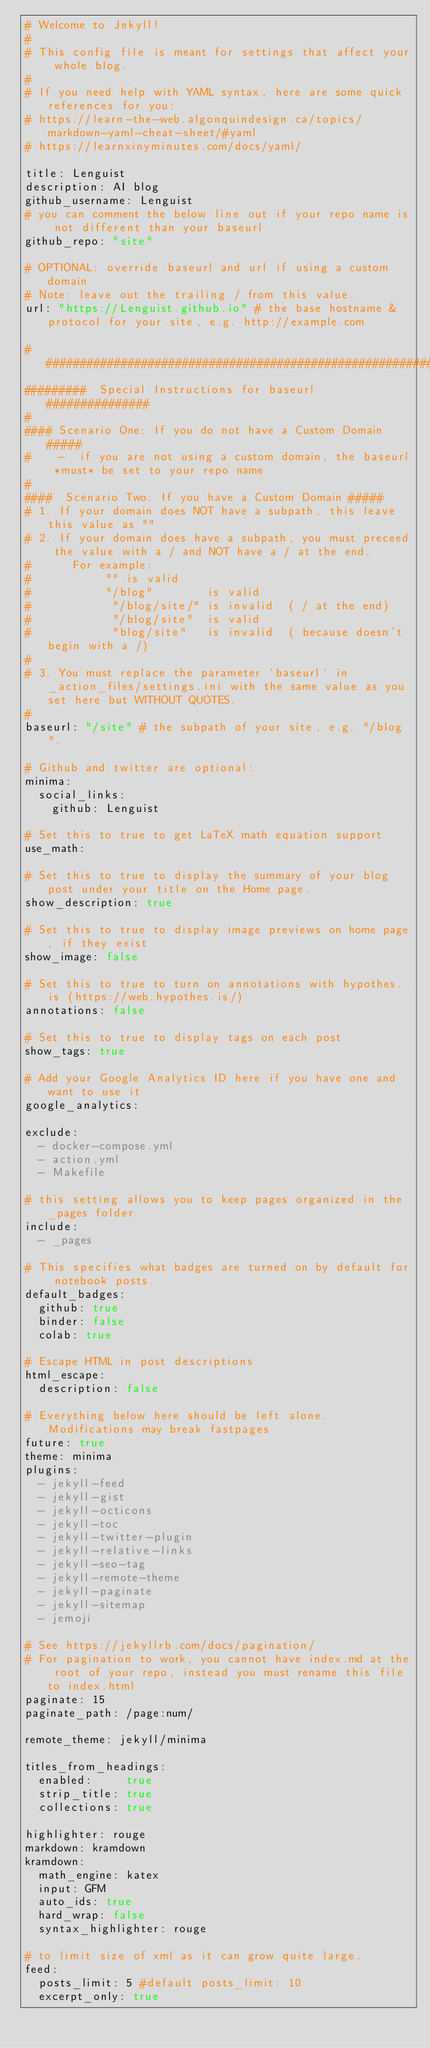Convert code to text. <code><loc_0><loc_0><loc_500><loc_500><_YAML_># Welcome to Jekyll!
#
# This config file is meant for settings that affect your whole blog.
#
# If you need help with YAML syntax, here are some quick references for you: 
# https://learn-the-web.algonquindesign.ca/topics/markdown-yaml-cheat-sheet/#yaml
# https://learnxinyminutes.com/docs/yaml/

title: Lenguist
description: AI blog
github_username: Lenguist
# you can comment the below line out if your repo name is not different than your baseurl
github_repo: "site"

# OPTIONAL: override baseurl and url if using a custom domain
# Note: leave out the trailing / from this value. 
url: "https://Lenguist.github.io" # the base hostname & protocol for your site, e.g. http://example.com

###########################################################
#########  Special Instructions for baseurl ###############
#
#### Scenario One: If you do not have a Custom Domain #####
#    -  if you are not using a custom domain, the baseurl *must* be set to your repo name
# 
####  Scenario Two: If you have a Custom Domain #####
# 1. If your domain does NOT have a subpath, this leave this value as ""
# 2. If your domain does have a subpath, you must preceed the value with a / and NOT have a / at the end.  
#      For example: 
#           "" is valid
#           "/blog"        is valid
#            "/blog/site/" is invalid  ( / at the end)
#            "/blog/site"  is valid
#            "blog/site"   is invalid  ( because doesn't begin with a /)
#
# 3. You must replace the parameter `baseurl` in _action_files/settings.ini with the same value as you set here but WITHOUT QUOTES.
#
baseurl: "/site" # the subpath of your site, e.g. "/blog".

# Github and twitter are optional:
minima:
  social_links:
    github: Lenguist

# Set this to true to get LaTeX math equation support
use_math: 

# Set this to true to display the summary of your blog post under your title on the Home page.
show_description: true

# Set this to true to display image previews on home page, if they exist
show_image: false

# Set this to true to turn on annotations with hypothes.is (https://web.hypothes.is/)
annotations: false

# Set this to true to display tags on each post
show_tags: true

# Add your Google Analytics ID here if you have one and want to use it
google_analytics: 

exclude:
  - docker-compose.yml
  - action.yml
  - Makefile

# this setting allows you to keep pages organized in the _pages folder
include:
  - _pages

# This specifies what badges are turned on by default for notebook posts.
default_badges:
  github: true
  binder: false
  colab: true

# Escape HTML in post descriptions
html_escape:
  description: false

# Everything below here should be left alone. Modifications may break fastpages
future: true
theme: minima
plugins:
  - jekyll-feed
  - jekyll-gist
  - jekyll-octicons
  - jekyll-toc
  - jekyll-twitter-plugin
  - jekyll-relative-links
  - jekyll-seo-tag
  - jekyll-remote-theme
  - jekyll-paginate
  - jekyll-sitemap
  - jemoji

# See https://jekyllrb.com/docs/pagination/
# For pagination to work, you cannot have index.md at the root of your repo, instead you must rename this file to index.html
paginate: 15
paginate_path: /page:num/

remote_theme: jekyll/minima

titles_from_headings:
  enabled:     true
  strip_title: true
  collections: true

highlighter: rouge
markdown: kramdown
kramdown:
  math_engine: katex
  input: GFM
  auto_ids: true
  hard_wrap: false
  syntax_highlighter: rouge

# to limit size of xml as it can grow quite large.
feed:
  posts_limit: 5 #default posts_limit: 10
  excerpt_only: true
</code> 